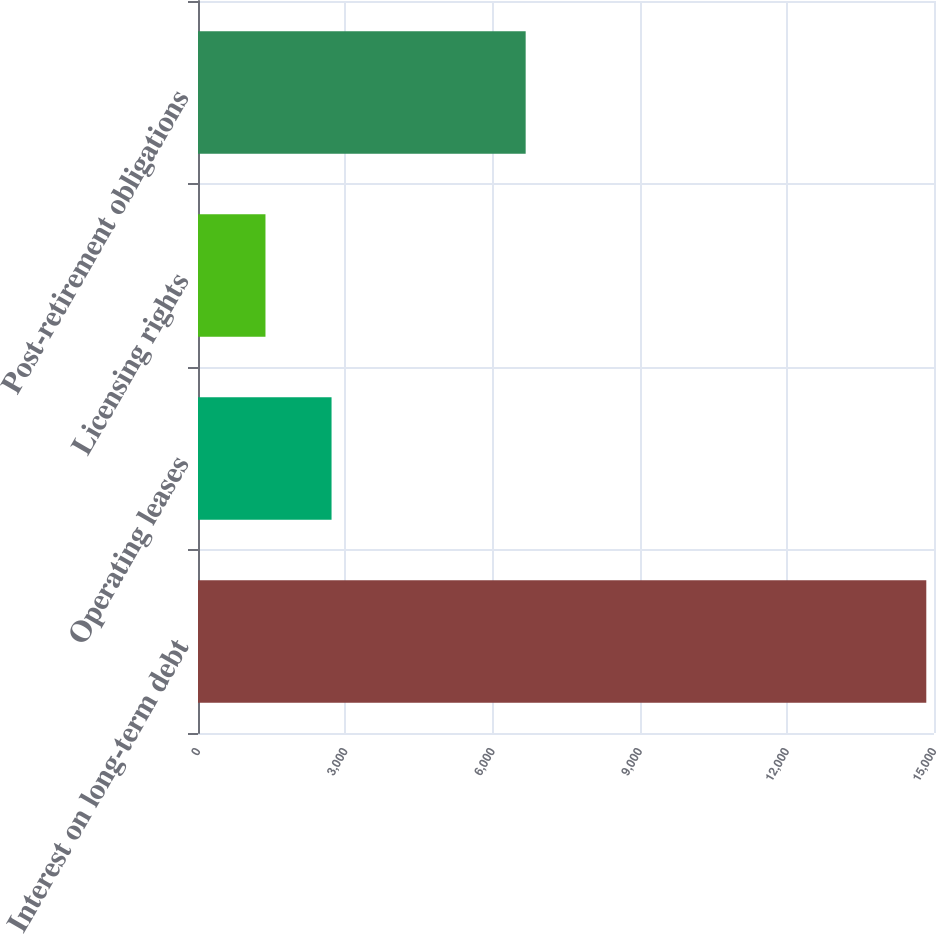Convert chart. <chart><loc_0><loc_0><loc_500><loc_500><bar_chart><fcel>Interest on long-term debt<fcel>Operating leases<fcel>Licensing rights<fcel>Post-retirement obligations<nl><fcel>14843<fcel>2721.8<fcel>1375<fcel>6678<nl></chart> 